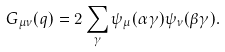Convert formula to latex. <formula><loc_0><loc_0><loc_500><loc_500>\ G _ { \mu \nu } ( q ) = 2 \sum _ { \gamma } \psi _ { \mu } ( \alpha \gamma ) \psi _ { \nu } ( \beta \gamma ) .</formula> 